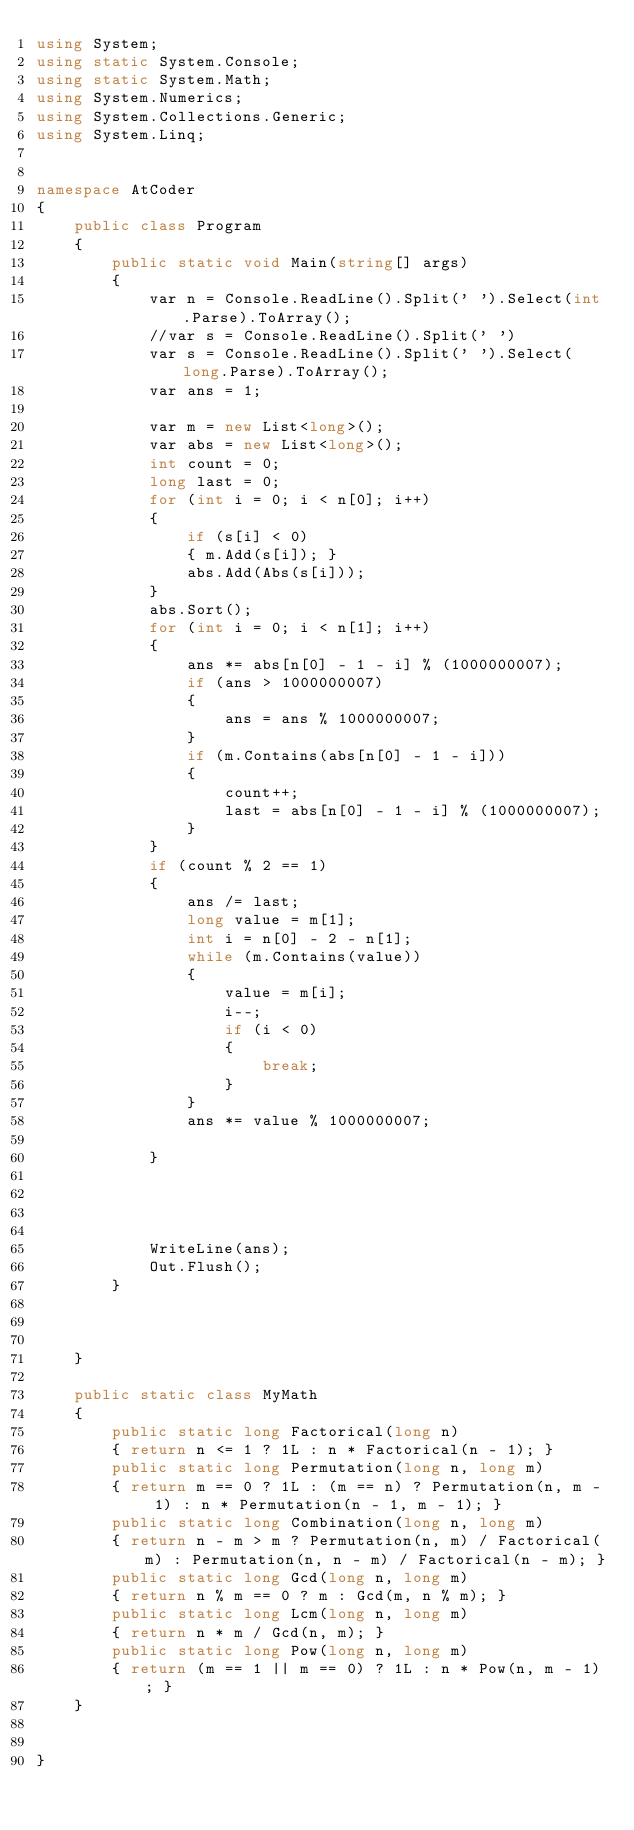<code> <loc_0><loc_0><loc_500><loc_500><_C#_>using System;
using static System.Console;
using static System.Math;
using System.Numerics;
using System.Collections.Generic;
using System.Linq;


namespace AtCoder
{
    public class Program
    {
        public static void Main(string[] args)
        {
            var n = Console.ReadLine().Split(' ').Select(int.Parse).ToArray();
            //var s = Console.ReadLine().Split(' ')
            var s = Console.ReadLine().Split(' ').Select(long.Parse).ToArray();
            var ans = 1;

            var m = new List<long>();
            var abs = new List<long>();
            int count = 0;
            long last = 0;
            for (int i = 0; i < n[0]; i++)
            {
                if (s[i] < 0)
                { m.Add(s[i]); }
                abs.Add(Abs(s[i]));
            }
            abs.Sort();
            for (int i = 0; i < n[1]; i++)
            {
                ans *= abs[n[0] - 1 - i] % (1000000007);
                if (ans > 1000000007)
                {
                    ans = ans % 1000000007;
                }
                if (m.Contains(abs[n[0] - 1 - i]))
                {
                    count++;
                    last = abs[n[0] - 1 - i] % (1000000007);
                }
            }
            if (count % 2 == 1)
            {
                ans /= last;
                long value = m[1];
                int i = n[0] - 2 - n[1];
                while (m.Contains(value))
                {
                    value = m[i];
                    i--;
                    if (i < 0)
                    {
                        break;
                    }
                }
                ans *= value % 1000000007;

            }




            WriteLine(ans);
            Out.Flush();
        }



    }

    public static class MyMath
    {
        public static long Factorical(long n)
        { return n <= 1 ? 1L : n * Factorical(n - 1); }
        public static long Permutation(long n, long m)
        { return m == 0 ? 1L : (m == n) ? Permutation(n, m - 1) : n * Permutation(n - 1, m - 1); }
        public static long Combination(long n, long m)
        { return n - m > m ? Permutation(n, m) / Factorical(m) : Permutation(n, n - m) / Factorical(n - m); }
        public static long Gcd(long n, long m)
        { return n % m == 0 ? m : Gcd(m, n % m); }
        public static long Lcm(long n, long m)
        { return n * m / Gcd(n, m); }
        public static long Pow(long n, long m)
        { return (m == 1 || m == 0) ? 1L : n * Pow(n, m - 1); }
    }


}</code> 